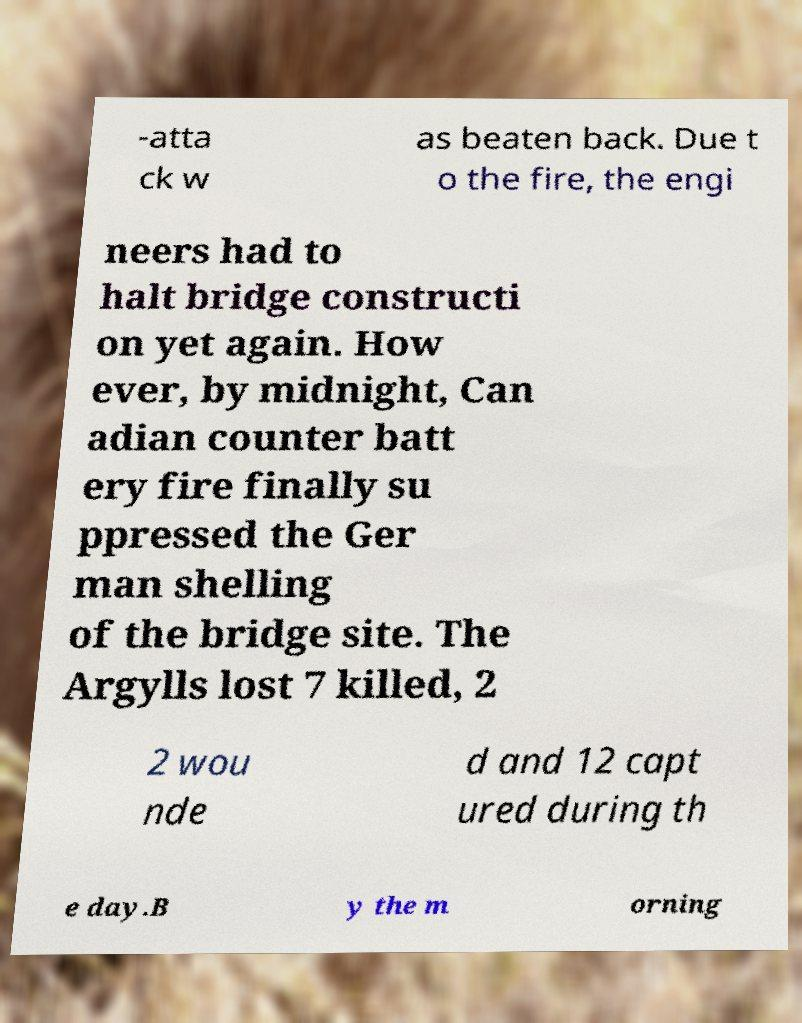Could you extract and type out the text from this image? -atta ck w as beaten back. Due t o the fire, the engi neers had to halt bridge constructi on yet again. How ever, by midnight, Can adian counter batt ery fire finally su ppressed the Ger man shelling of the bridge site. The Argylls lost 7 killed, 2 2 wou nde d and 12 capt ured during th e day.B y the m orning 